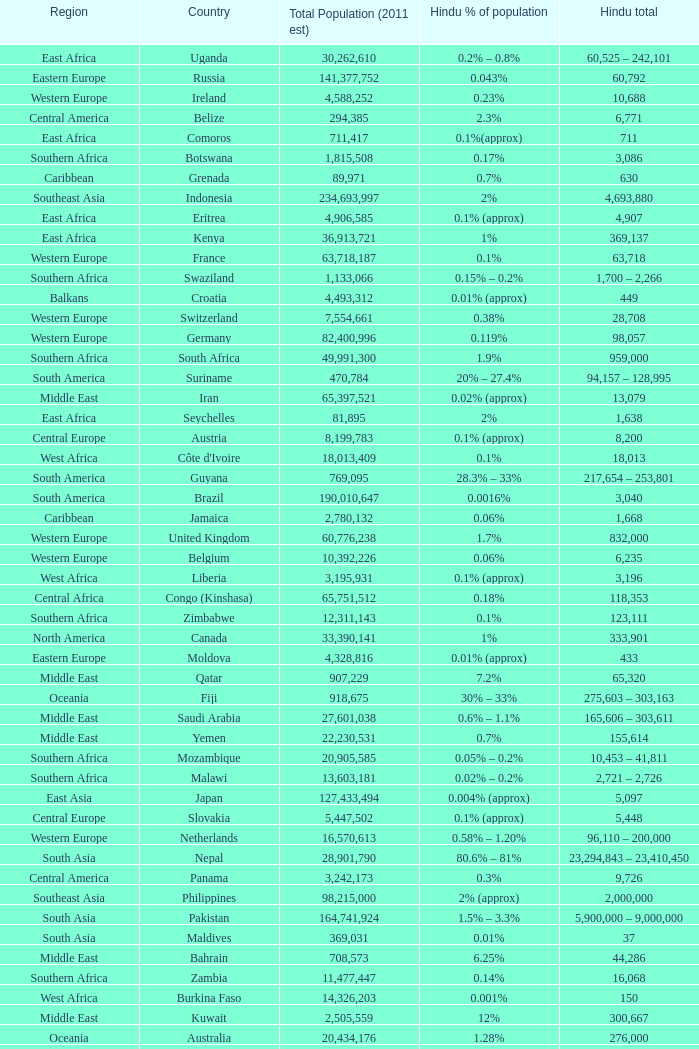Total Population (2011 est) larger than 30,262,610, and a Hindu total of 63,718 involves what country? France. 